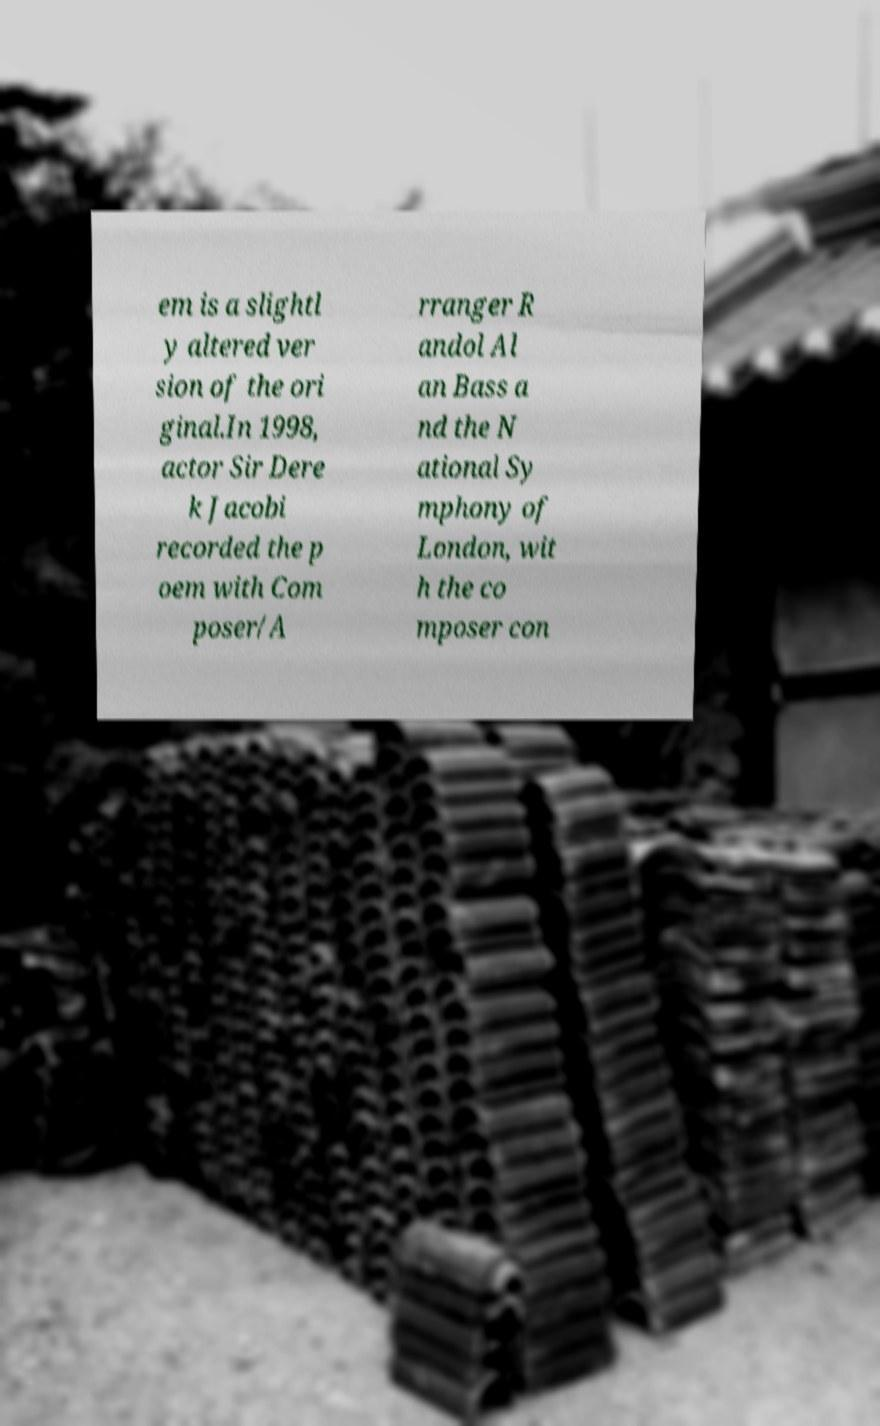Can you read and provide the text displayed in the image?This photo seems to have some interesting text. Can you extract and type it out for me? em is a slightl y altered ver sion of the ori ginal.In 1998, actor Sir Dere k Jacobi recorded the p oem with Com poser/A rranger R andol Al an Bass a nd the N ational Sy mphony of London, wit h the co mposer con 